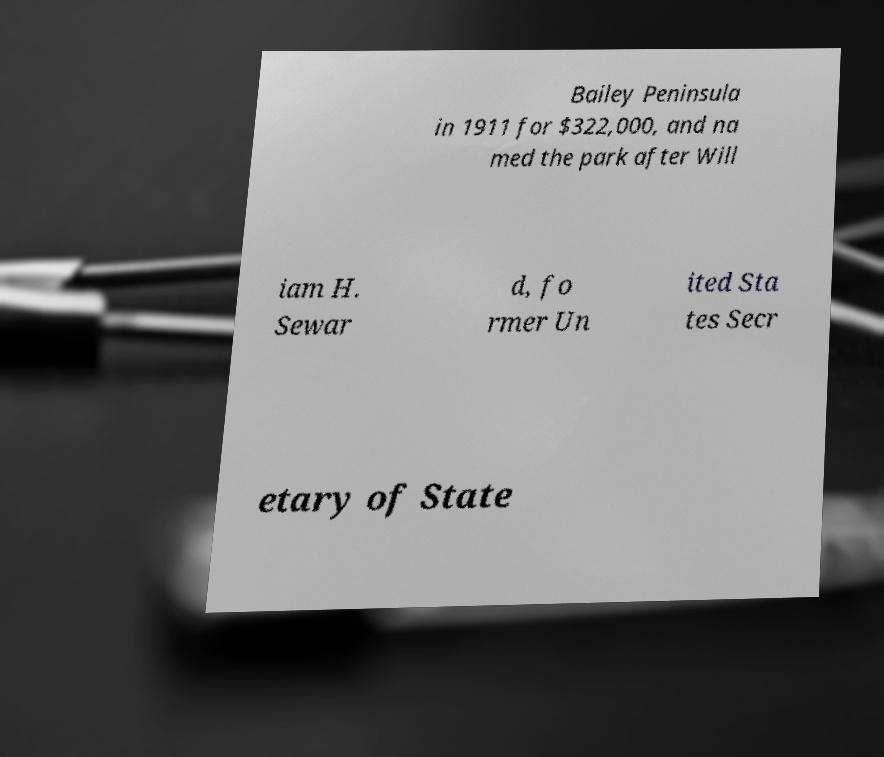Please read and relay the text visible in this image. What does it say? Bailey Peninsula in 1911 for $322,000, and na med the park after Will iam H. Sewar d, fo rmer Un ited Sta tes Secr etary of State 